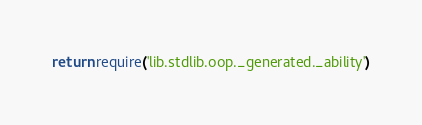<code> <loc_0><loc_0><loc_500><loc_500><_Lua_>return require('lib.stdlib.oop._generated._ability')
</code> 